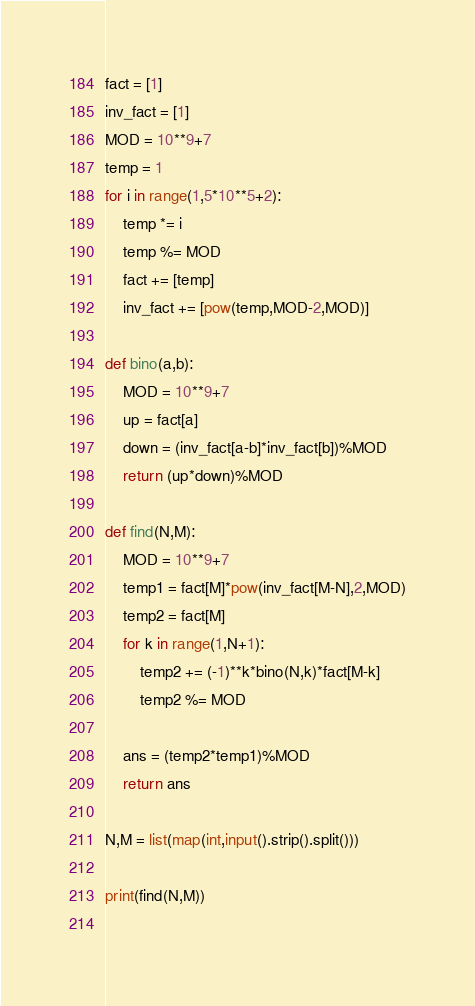Convert code to text. <code><loc_0><loc_0><loc_500><loc_500><_Python_>fact = [1]
inv_fact = [1]
MOD = 10**9+7
temp = 1
for i in range(1,5*10**5+2):
    temp *= i
    temp %= MOD
    fact += [temp]
    inv_fact += [pow(temp,MOD-2,MOD)]

def bino(a,b):
    MOD = 10**9+7
    up = fact[a]
    down = (inv_fact[a-b]*inv_fact[b])%MOD
    return (up*down)%MOD

def find(N,M):
    MOD = 10**9+7
    temp1 = fact[M]*pow(inv_fact[M-N],2,MOD)
    temp2 = fact[M]
    for k in range(1,N+1):
        temp2 += (-1)**k*bino(N,k)*fact[M-k]
        temp2 %= MOD
    
    ans = (temp2*temp1)%MOD
    return ans

N,M = list(map(int,input().strip().split()))

print(find(N,M))
    
</code> 